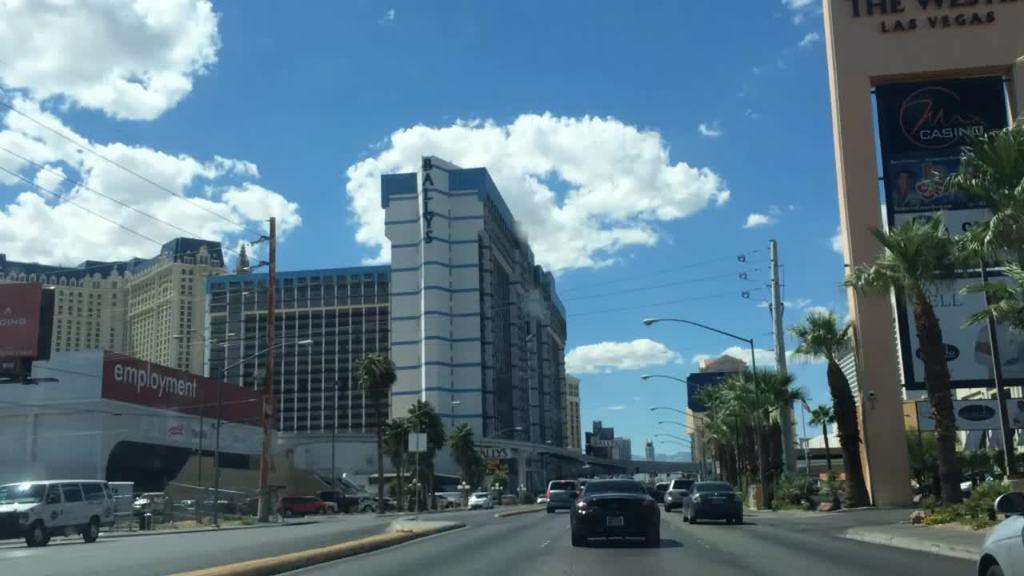In one or two sentences, can you explain what this image depicts? In this image we can see vehicles on the road. On the sides of the road there are trees, electric poles with wires and light poles. Also there are buildings. Also there are boards with some text. In the background there is sky with clouds. 